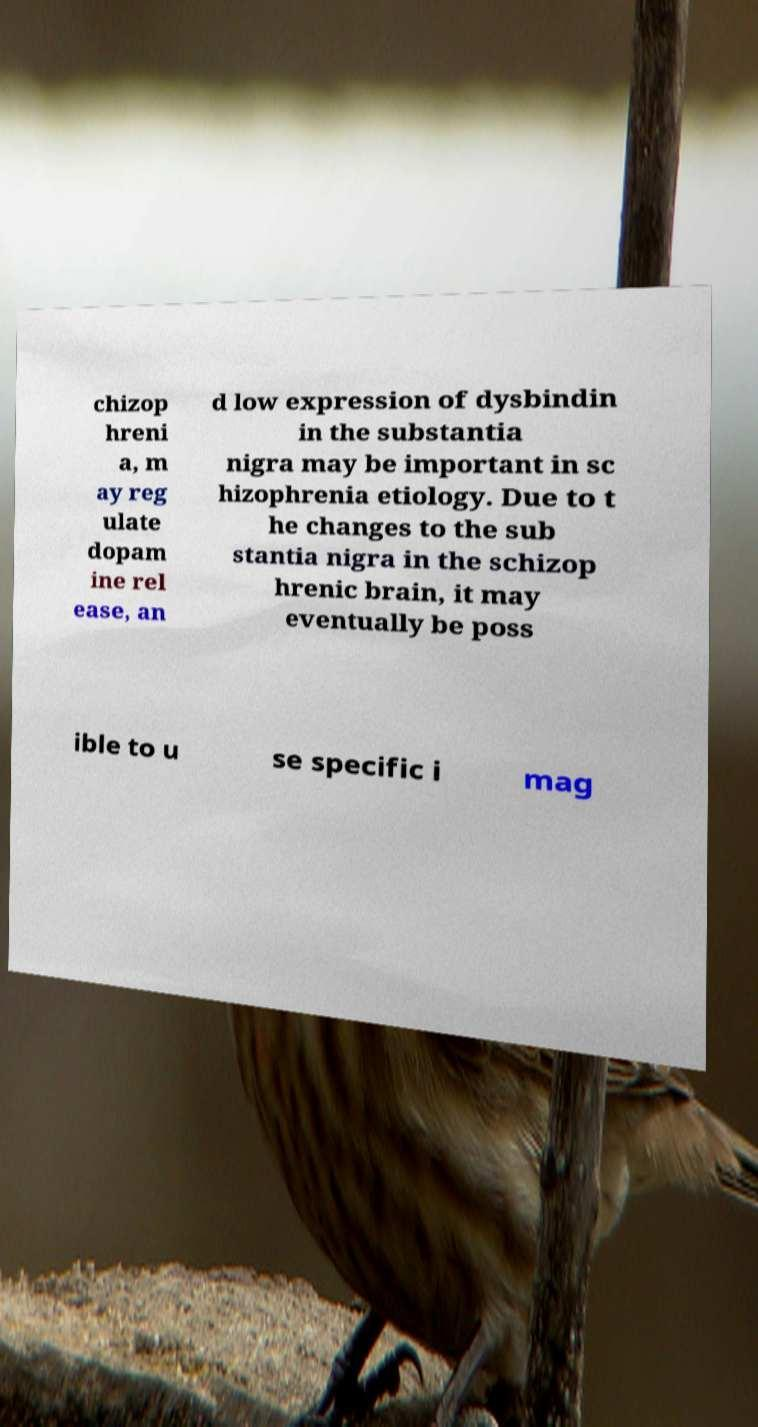Can you read and provide the text displayed in the image?This photo seems to have some interesting text. Can you extract and type it out for me? chizop hreni a, m ay reg ulate dopam ine rel ease, an d low expression of dysbindin in the substantia nigra may be important in sc hizophrenia etiology. Due to t he changes to the sub stantia nigra in the schizop hrenic brain, it may eventually be poss ible to u se specific i mag 